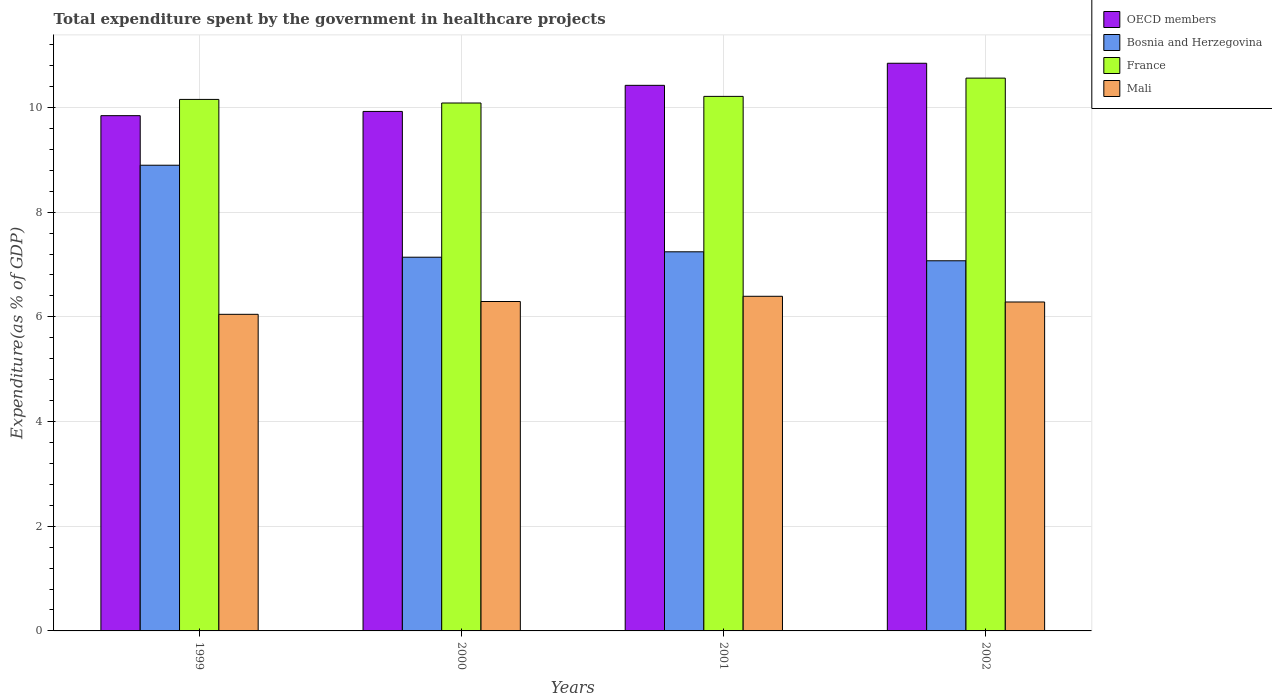How many groups of bars are there?
Your response must be concise. 4. Are the number of bars per tick equal to the number of legend labels?
Your answer should be compact. Yes. How many bars are there on the 2nd tick from the left?
Offer a terse response. 4. How many bars are there on the 1st tick from the right?
Provide a short and direct response. 4. In how many cases, is the number of bars for a given year not equal to the number of legend labels?
Your answer should be very brief. 0. What is the total expenditure spent by the government in healthcare projects in Mali in 2000?
Your response must be concise. 6.29. Across all years, what is the maximum total expenditure spent by the government in healthcare projects in France?
Give a very brief answer. 10.56. Across all years, what is the minimum total expenditure spent by the government in healthcare projects in Mali?
Your response must be concise. 6.05. In which year was the total expenditure spent by the government in healthcare projects in Bosnia and Herzegovina maximum?
Provide a short and direct response. 1999. What is the total total expenditure spent by the government in healthcare projects in Bosnia and Herzegovina in the graph?
Keep it short and to the point. 30.35. What is the difference between the total expenditure spent by the government in healthcare projects in Bosnia and Herzegovina in 2000 and that in 2002?
Make the answer very short. 0.07. What is the difference between the total expenditure spent by the government in healthcare projects in Bosnia and Herzegovina in 2000 and the total expenditure spent by the government in healthcare projects in Mali in 2002?
Offer a terse response. 0.86. What is the average total expenditure spent by the government in healthcare projects in Mali per year?
Offer a terse response. 6.25. In the year 2002, what is the difference between the total expenditure spent by the government in healthcare projects in Bosnia and Herzegovina and total expenditure spent by the government in healthcare projects in OECD members?
Give a very brief answer. -3.77. In how many years, is the total expenditure spent by the government in healthcare projects in France greater than 2 %?
Offer a very short reply. 4. What is the ratio of the total expenditure spent by the government in healthcare projects in Bosnia and Herzegovina in 1999 to that in 2002?
Give a very brief answer. 1.26. What is the difference between the highest and the second highest total expenditure spent by the government in healthcare projects in France?
Ensure brevity in your answer.  0.35. What is the difference between the highest and the lowest total expenditure spent by the government in healthcare projects in France?
Offer a very short reply. 0.48. In how many years, is the total expenditure spent by the government in healthcare projects in Mali greater than the average total expenditure spent by the government in healthcare projects in Mali taken over all years?
Give a very brief answer. 3. Is the sum of the total expenditure spent by the government in healthcare projects in France in 2001 and 2002 greater than the maximum total expenditure spent by the government in healthcare projects in Bosnia and Herzegovina across all years?
Your answer should be compact. Yes. What does the 4th bar from the left in 2001 represents?
Your answer should be very brief. Mali. How many bars are there?
Provide a short and direct response. 16. Are all the bars in the graph horizontal?
Offer a terse response. No. How many years are there in the graph?
Your answer should be very brief. 4. Does the graph contain grids?
Ensure brevity in your answer.  Yes. Where does the legend appear in the graph?
Your response must be concise. Top right. How are the legend labels stacked?
Keep it short and to the point. Vertical. What is the title of the graph?
Your answer should be very brief. Total expenditure spent by the government in healthcare projects. What is the label or title of the X-axis?
Your response must be concise. Years. What is the label or title of the Y-axis?
Offer a terse response. Expenditure(as % of GDP). What is the Expenditure(as % of GDP) in OECD members in 1999?
Your answer should be very brief. 9.84. What is the Expenditure(as % of GDP) in Bosnia and Herzegovina in 1999?
Your answer should be very brief. 8.9. What is the Expenditure(as % of GDP) of France in 1999?
Your answer should be very brief. 10.15. What is the Expenditure(as % of GDP) of Mali in 1999?
Provide a succinct answer. 6.05. What is the Expenditure(as % of GDP) of OECD members in 2000?
Your response must be concise. 9.92. What is the Expenditure(as % of GDP) of Bosnia and Herzegovina in 2000?
Give a very brief answer. 7.14. What is the Expenditure(as % of GDP) of France in 2000?
Provide a succinct answer. 10.08. What is the Expenditure(as % of GDP) of Mali in 2000?
Give a very brief answer. 6.29. What is the Expenditure(as % of GDP) of OECD members in 2001?
Offer a very short reply. 10.42. What is the Expenditure(as % of GDP) in Bosnia and Herzegovina in 2001?
Provide a short and direct response. 7.24. What is the Expenditure(as % of GDP) of France in 2001?
Provide a short and direct response. 10.21. What is the Expenditure(as % of GDP) in Mali in 2001?
Make the answer very short. 6.39. What is the Expenditure(as % of GDP) in OECD members in 2002?
Give a very brief answer. 10.84. What is the Expenditure(as % of GDP) in Bosnia and Herzegovina in 2002?
Give a very brief answer. 7.07. What is the Expenditure(as % of GDP) of France in 2002?
Your response must be concise. 10.56. What is the Expenditure(as % of GDP) of Mali in 2002?
Offer a very short reply. 6.28. Across all years, what is the maximum Expenditure(as % of GDP) in OECD members?
Offer a very short reply. 10.84. Across all years, what is the maximum Expenditure(as % of GDP) in Bosnia and Herzegovina?
Offer a very short reply. 8.9. Across all years, what is the maximum Expenditure(as % of GDP) in France?
Keep it short and to the point. 10.56. Across all years, what is the maximum Expenditure(as % of GDP) in Mali?
Offer a very short reply. 6.39. Across all years, what is the minimum Expenditure(as % of GDP) in OECD members?
Provide a succinct answer. 9.84. Across all years, what is the minimum Expenditure(as % of GDP) of Bosnia and Herzegovina?
Keep it short and to the point. 7.07. Across all years, what is the minimum Expenditure(as % of GDP) of France?
Give a very brief answer. 10.08. Across all years, what is the minimum Expenditure(as % of GDP) of Mali?
Offer a very short reply. 6.05. What is the total Expenditure(as % of GDP) in OECD members in the graph?
Give a very brief answer. 41.03. What is the total Expenditure(as % of GDP) of Bosnia and Herzegovina in the graph?
Provide a short and direct response. 30.35. What is the total Expenditure(as % of GDP) in France in the graph?
Offer a terse response. 41.01. What is the total Expenditure(as % of GDP) of Mali in the graph?
Your answer should be very brief. 25.02. What is the difference between the Expenditure(as % of GDP) in OECD members in 1999 and that in 2000?
Your response must be concise. -0.08. What is the difference between the Expenditure(as % of GDP) of Bosnia and Herzegovina in 1999 and that in 2000?
Provide a succinct answer. 1.76. What is the difference between the Expenditure(as % of GDP) of France in 1999 and that in 2000?
Your answer should be very brief. 0.07. What is the difference between the Expenditure(as % of GDP) in Mali in 1999 and that in 2000?
Provide a short and direct response. -0.24. What is the difference between the Expenditure(as % of GDP) in OECD members in 1999 and that in 2001?
Provide a short and direct response. -0.58. What is the difference between the Expenditure(as % of GDP) of Bosnia and Herzegovina in 1999 and that in 2001?
Keep it short and to the point. 1.65. What is the difference between the Expenditure(as % of GDP) in France in 1999 and that in 2001?
Make the answer very short. -0.06. What is the difference between the Expenditure(as % of GDP) in Mali in 1999 and that in 2001?
Provide a short and direct response. -0.34. What is the difference between the Expenditure(as % of GDP) of OECD members in 1999 and that in 2002?
Provide a short and direct response. -1. What is the difference between the Expenditure(as % of GDP) of Bosnia and Herzegovina in 1999 and that in 2002?
Provide a short and direct response. 1.83. What is the difference between the Expenditure(as % of GDP) of France in 1999 and that in 2002?
Keep it short and to the point. -0.41. What is the difference between the Expenditure(as % of GDP) in Mali in 1999 and that in 2002?
Provide a short and direct response. -0.24. What is the difference between the Expenditure(as % of GDP) in OECD members in 2000 and that in 2001?
Offer a very short reply. -0.5. What is the difference between the Expenditure(as % of GDP) in Bosnia and Herzegovina in 2000 and that in 2001?
Offer a very short reply. -0.1. What is the difference between the Expenditure(as % of GDP) in France in 2000 and that in 2001?
Ensure brevity in your answer.  -0.13. What is the difference between the Expenditure(as % of GDP) of Mali in 2000 and that in 2001?
Make the answer very short. -0.1. What is the difference between the Expenditure(as % of GDP) in OECD members in 2000 and that in 2002?
Provide a short and direct response. -0.92. What is the difference between the Expenditure(as % of GDP) of Bosnia and Herzegovina in 2000 and that in 2002?
Your answer should be very brief. 0.07. What is the difference between the Expenditure(as % of GDP) of France in 2000 and that in 2002?
Provide a succinct answer. -0.48. What is the difference between the Expenditure(as % of GDP) in Mali in 2000 and that in 2002?
Keep it short and to the point. 0.01. What is the difference between the Expenditure(as % of GDP) of OECD members in 2001 and that in 2002?
Give a very brief answer. -0.42. What is the difference between the Expenditure(as % of GDP) of Bosnia and Herzegovina in 2001 and that in 2002?
Your answer should be compact. 0.17. What is the difference between the Expenditure(as % of GDP) in France in 2001 and that in 2002?
Provide a succinct answer. -0.35. What is the difference between the Expenditure(as % of GDP) in Mali in 2001 and that in 2002?
Give a very brief answer. 0.11. What is the difference between the Expenditure(as % of GDP) of OECD members in 1999 and the Expenditure(as % of GDP) of Bosnia and Herzegovina in 2000?
Ensure brevity in your answer.  2.7. What is the difference between the Expenditure(as % of GDP) of OECD members in 1999 and the Expenditure(as % of GDP) of France in 2000?
Your response must be concise. -0.24. What is the difference between the Expenditure(as % of GDP) in OECD members in 1999 and the Expenditure(as % of GDP) in Mali in 2000?
Provide a short and direct response. 3.55. What is the difference between the Expenditure(as % of GDP) of Bosnia and Herzegovina in 1999 and the Expenditure(as % of GDP) of France in 2000?
Offer a very short reply. -1.19. What is the difference between the Expenditure(as % of GDP) in Bosnia and Herzegovina in 1999 and the Expenditure(as % of GDP) in Mali in 2000?
Offer a very short reply. 2.6. What is the difference between the Expenditure(as % of GDP) of France in 1999 and the Expenditure(as % of GDP) of Mali in 2000?
Keep it short and to the point. 3.86. What is the difference between the Expenditure(as % of GDP) of OECD members in 1999 and the Expenditure(as % of GDP) of Bosnia and Herzegovina in 2001?
Give a very brief answer. 2.6. What is the difference between the Expenditure(as % of GDP) in OECD members in 1999 and the Expenditure(as % of GDP) in France in 2001?
Your answer should be very brief. -0.37. What is the difference between the Expenditure(as % of GDP) of OECD members in 1999 and the Expenditure(as % of GDP) of Mali in 2001?
Your answer should be very brief. 3.45. What is the difference between the Expenditure(as % of GDP) in Bosnia and Herzegovina in 1999 and the Expenditure(as % of GDP) in France in 2001?
Keep it short and to the point. -1.31. What is the difference between the Expenditure(as % of GDP) in Bosnia and Herzegovina in 1999 and the Expenditure(as % of GDP) in Mali in 2001?
Your answer should be very brief. 2.5. What is the difference between the Expenditure(as % of GDP) of France in 1999 and the Expenditure(as % of GDP) of Mali in 2001?
Ensure brevity in your answer.  3.76. What is the difference between the Expenditure(as % of GDP) in OECD members in 1999 and the Expenditure(as % of GDP) in Bosnia and Herzegovina in 2002?
Your answer should be very brief. 2.77. What is the difference between the Expenditure(as % of GDP) in OECD members in 1999 and the Expenditure(as % of GDP) in France in 2002?
Offer a terse response. -0.72. What is the difference between the Expenditure(as % of GDP) in OECD members in 1999 and the Expenditure(as % of GDP) in Mali in 2002?
Your response must be concise. 3.56. What is the difference between the Expenditure(as % of GDP) of Bosnia and Herzegovina in 1999 and the Expenditure(as % of GDP) of France in 2002?
Provide a succinct answer. -1.66. What is the difference between the Expenditure(as % of GDP) in Bosnia and Herzegovina in 1999 and the Expenditure(as % of GDP) in Mali in 2002?
Provide a short and direct response. 2.61. What is the difference between the Expenditure(as % of GDP) of France in 1999 and the Expenditure(as % of GDP) of Mali in 2002?
Your response must be concise. 3.87. What is the difference between the Expenditure(as % of GDP) of OECD members in 2000 and the Expenditure(as % of GDP) of Bosnia and Herzegovina in 2001?
Give a very brief answer. 2.68. What is the difference between the Expenditure(as % of GDP) in OECD members in 2000 and the Expenditure(as % of GDP) in France in 2001?
Your answer should be very brief. -0.29. What is the difference between the Expenditure(as % of GDP) in OECD members in 2000 and the Expenditure(as % of GDP) in Mali in 2001?
Provide a succinct answer. 3.53. What is the difference between the Expenditure(as % of GDP) in Bosnia and Herzegovina in 2000 and the Expenditure(as % of GDP) in France in 2001?
Provide a short and direct response. -3.07. What is the difference between the Expenditure(as % of GDP) in Bosnia and Herzegovina in 2000 and the Expenditure(as % of GDP) in Mali in 2001?
Offer a very short reply. 0.75. What is the difference between the Expenditure(as % of GDP) in France in 2000 and the Expenditure(as % of GDP) in Mali in 2001?
Ensure brevity in your answer.  3.69. What is the difference between the Expenditure(as % of GDP) of OECD members in 2000 and the Expenditure(as % of GDP) of Bosnia and Herzegovina in 2002?
Provide a succinct answer. 2.85. What is the difference between the Expenditure(as % of GDP) of OECD members in 2000 and the Expenditure(as % of GDP) of France in 2002?
Offer a very short reply. -0.64. What is the difference between the Expenditure(as % of GDP) of OECD members in 2000 and the Expenditure(as % of GDP) of Mali in 2002?
Make the answer very short. 3.64. What is the difference between the Expenditure(as % of GDP) in Bosnia and Herzegovina in 2000 and the Expenditure(as % of GDP) in France in 2002?
Offer a terse response. -3.42. What is the difference between the Expenditure(as % of GDP) of Bosnia and Herzegovina in 2000 and the Expenditure(as % of GDP) of Mali in 2002?
Your answer should be compact. 0.86. What is the difference between the Expenditure(as % of GDP) of France in 2000 and the Expenditure(as % of GDP) of Mali in 2002?
Offer a very short reply. 3.8. What is the difference between the Expenditure(as % of GDP) in OECD members in 2001 and the Expenditure(as % of GDP) in Bosnia and Herzegovina in 2002?
Provide a short and direct response. 3.35. What is the difference between the Expenditure(as % of GDP) of OECD members in 2001 and the Expenditure(as % of GDP) of France in 2002?
Your answer should be compact. -0.14. What is the difference between the Expenditure(as % of GDP) in OECD members in 2001 and the Expenditure(as % of GDP) in Mali in 2002?
Provide a succinct answer. 4.14. What is the difference between the Expenditure(as % of GDP) in Bosnia and Herzegovina in 2001 and the Expenditure(as % of GDP) in France in 2002?
Offer a terse response. -3.32. What is the difference between the Expenditure(as % of GDP) in Bosnia and Herzegovina in 2001 and the Expenditure(as % of GDP) in Mali in 2002?
Give a very brief answer. 0.96. What is the difference between the Expenditure(as % of GDP) of France in 2001 and the Expenditure(as % of GDP) of Mali in 2002?
Your answer should be very brief. 3.93. What is the average Expenditure(as % of GDP) of OECD members per year?
Offer a very short reply. 10.26. What is the average Expenditure(as % of GDP) of Bosnia and Herzegovina per year?
Keep it short and to the point. 7.59. What is the average Expenditure(as % of GDP) in France per year?
Ensure brevity in your answer.  10.25. What is the average Expenditure(as % of GDP) in Mali per year?
Give a very brief answer. 6.25. In the year 1999, what is the difference between the Expenditure(as % of GDP) in OECD members and Expenditure(as % of GDP) in Bosnia and Herzegovina?
Your answer should be very brief. 0.95. In the year 1999, what is the difference between the Expenditure(as % of GDP) in OECD members and Expenditure(as % of GDP) in France?
Give a very brief answer. -0.31. In the year 1999, what is the difference between the Expenditure(as % of GDP) of OECD members and Expenditure(as % of GDP) of Mali?
Give a very brief answer. 3.79. In the year 1999, what is the difference between the Expenditure(as % of GDP) in Bosnia and Herzegovina and Expenditure(as % of GDP) in France?
Make the answer very short. -1.26. In the year 1999, what is the difference between the Expenditure(as % of GDP) of Bosnia and Herzegovina and Expenditure(as % of GDP) of Mali?
Your answer should be very brief. 2.85. In the year 1999, what is the difference between the Expenditure(as % of GDP) of France and Expenditure(as % of GDP) of Mali?
Give a very brief answer. 4.11. In the year 2000, what is the difference between the Expenditure(as % of GDP) in OECD members and Expenditure(as % of GDP) in Bosnia and Herzegovina?
Provide a short and direct response. 2.78. In the year 2000, what is the difference between the Expenditure(as % of GDP) in OECD members and Expenditure(as % of GDP) in France?
Your response must be concise. -0.16. In the year 2000, what is the difference between the Expenditure(as % of GDP) in OECD members and Expenditure(as % of GDP) in Mali?
Make the answer very short. 3.63. In the year 2000, what is the difference between the Expenditure(as % of GDP) of Bosnia and Herzegovina and Expenditure(as % of GDP) of France?
Your answer should be compact. -2.95. In the year 2000, what is the difference between the Expenditure(as % of GDP) in Bosnia and Herzegovina and Expenditure(as % of GDP) in Mali?
Offer a very short reply. 0.85. In the year 2000, what is the difference between the Expenditure(as % of GDP) of France and Expenditure(as % of GDP) of Mali?
Offer a terse response. 3.79. In the year 2001, what is the difference between the Expenditure(as % of GDP) of OECD members and Expenditure(as % of GDP) of Bosnia and Herzegovina?
Offer a terse response. 3.18. In the year 2001, what is the difference between the Expenditure(as % of GDP) in OECD members and Expenditure(as % of GDP) in France?
Your answer should be very brief. 0.21. In the year 2001, what is the difference between the Expenditure(as % of GDP) of OECD members and Expenditure(as % of GDP) of Mali?
Keep it short and to the point. 4.03. In the year 2001, what is the difference between the Expenditure(as % of GDP) in Bosnia and Herzegovina and Expenditure(as % of GDP) in France?
Give a very brief answer. -2.97. In the year 2001, what is the difference between the Expenditure(as % of GDP) in Bosnia and Herzegovina and Expenditure(as % of GDP) in Mali?
Provide a succinct answer. 0.85. In the year 2001, what is the difference between the Expenditure(as % of GDP) of France and Expenditure(as % of GDP) of Mali?
Keep it short and to the point. 3.82. In the year 2002, what is the difference between the Expenditure(as % of GDP) of OECD members and Expenditure(as % of GDP) of Bosnia and Herzegovina?
Your answer should be compact. 3.77. In the year 2002, what is the difference between the Expenditure(as % of GDP) of OECD members and Expenditure(as % of GDP) of France?
Your response must be concise. 0.28. In the year 2002, what is the difference between the Expenditure(as % of GDP) of OECD members and Expenditure(as % of GDP) of Mali?
Offer a very short reply. 4.56. In the year 2002, what is the difference between the Expenditure(as % of GDP) of Bosnia and Herzegovina and Expenditure(as % of GDP) of France?
Ensure brevity in your answer.  -3.49. In the year 2002, what is the difference between the Expenditure(as % of GDP) of Bosnia and Herzegovina and Expenditure(as % of GDP) of Mali?
Ensure brevity in your answer.  0.79. In the year 2002, what is the difference between the Expenditure(as % of GDP) in France and Expenditure(as % of GDP) in Mali?
Offer a terse response. 4.28. What is the ratio of the Expenditure(as % of GDP) in OECD members in 1999 to that in 2000?
Make the answer very short. 0.99. What is the ratio of the Expenditure(as % of GDP) in Bosnia and Herzegovina in 1999 to that in 2000?
Give a very brief answer. 1.25. What is the ratio of the Expenditure(as % of GDP) in France in 1999 to that in 2000?
Give a very brief answer. 1.01. What is the ratio of the Expenditure(as % of GDP) in Mali in 1999 to that in 2000?
Your answer should be very brief. 0.96. What is the ratio of the Expenditure(as % of GDP) in Bosnia and Herzegovina in 1999 to that in 2001?
Give a very brief answer. 1.23. What is the ratio of the Expenditure(as % of GDP) of Mali in 1999 to that in 2001?
Your answer should be compact. 0.95. What is the ratio of the Expenditure(as % of GDP) in OECD members in 1999 to that in 2002?
Offer a very short reply. 0.91. What is the ratio of the Expenditure(as % of GDP) in Bosnia and Herzegovina in 1999 to that in 2002?
Your response must be concise. 1.26. What is the ratio of the Expenditure(as % of GDP) in France in 1999 to that in 2002?
Your answer should be very brief. 0.96. What is the ratio of the Expenditure(as % of GDP) in Mali in 1999 to that in 2002?
Give a very brief answer. 0.96. What is the ratio of the Expenditure(as % of GDP) in OECD members in 2000 to that in 2001?
Keep it short and to the point. 0.95. What is the ratio of the Expenditure(as % of GDP) of Bosnia and Herzegovina in 2000 to that in 2001?
Give a very brief answer. 0.99. What is the ratio of the Expenditure(as % of GDP) in France in 2000 to that in 2001?
Provide a short and direct response. 0.99. What is the ratio of the Expenditure(as % of GDP) in Mali in 2000 to that in 2001?
Your answer should be very brief. 0.98. What is the ratio of the Expenditure(as % of GDP) of OECD members in 2000 to that in 2002?
Your answer should be very brief. 0.92. What is the ratio of the Expenditure(as % of GDP) in Bosnia and Herzegovina in 2000 to that in 2002?
Make the answer very short. 1.01. What is the ratio of the Expenditure(as % of GDP) in France in 2000 to that in 2002?
Make the answer very short. 0.95. What is the ratio of the Expenditure(as % of GDP) of OECD members in 2001 to that in 2002?
Offer a very short reply. 0.96. What is the ratio of the Expenditure(as % of GDP) of Bosnia and Herzegovina in 2001 to that in 2002?
Offer a terse response. 1.02. What is the ratio of the Expenditure(as % of GDP) in Mali in 2001 to that in 2002?
Make the answer very short. 1.02. What is the difference between the highest and the second highest Expenditure(as % of GDP) in OECD members?
Provide a short and direct response. 0.42. What is the difference between the highest and the second highest Expenditure(as % of GDP) of Bosnia and Herzegovina?
Make the answer very short. 1.65. What is the difference between the highest and the second highest Expenditure(as % of GDP) in France?
Offer a very short reply. 0.35. What is the difference between the highest and the second highest Expenditure(as % of GDP) of Mali?
Offer a very short reply. 0.1. What is the difference between the highest and the lowest Expenditure(as % of GDP) of OECD members?
Ensure brevity in your answer.  1. What is the difference between the highest and the lowest Expenditure(as % of GDP) in Bosnia and Herzegovina?
Make the answer very short. 1.83. What is the difference between the highest and the lowest Expenditure(as % of GDP) of France?
Your response must be concise. 0.48. What is the difference between the highest and the lowest Expenditure(as % of GDP) in Mali?
Ensure brevity in your answer.  0.34. 